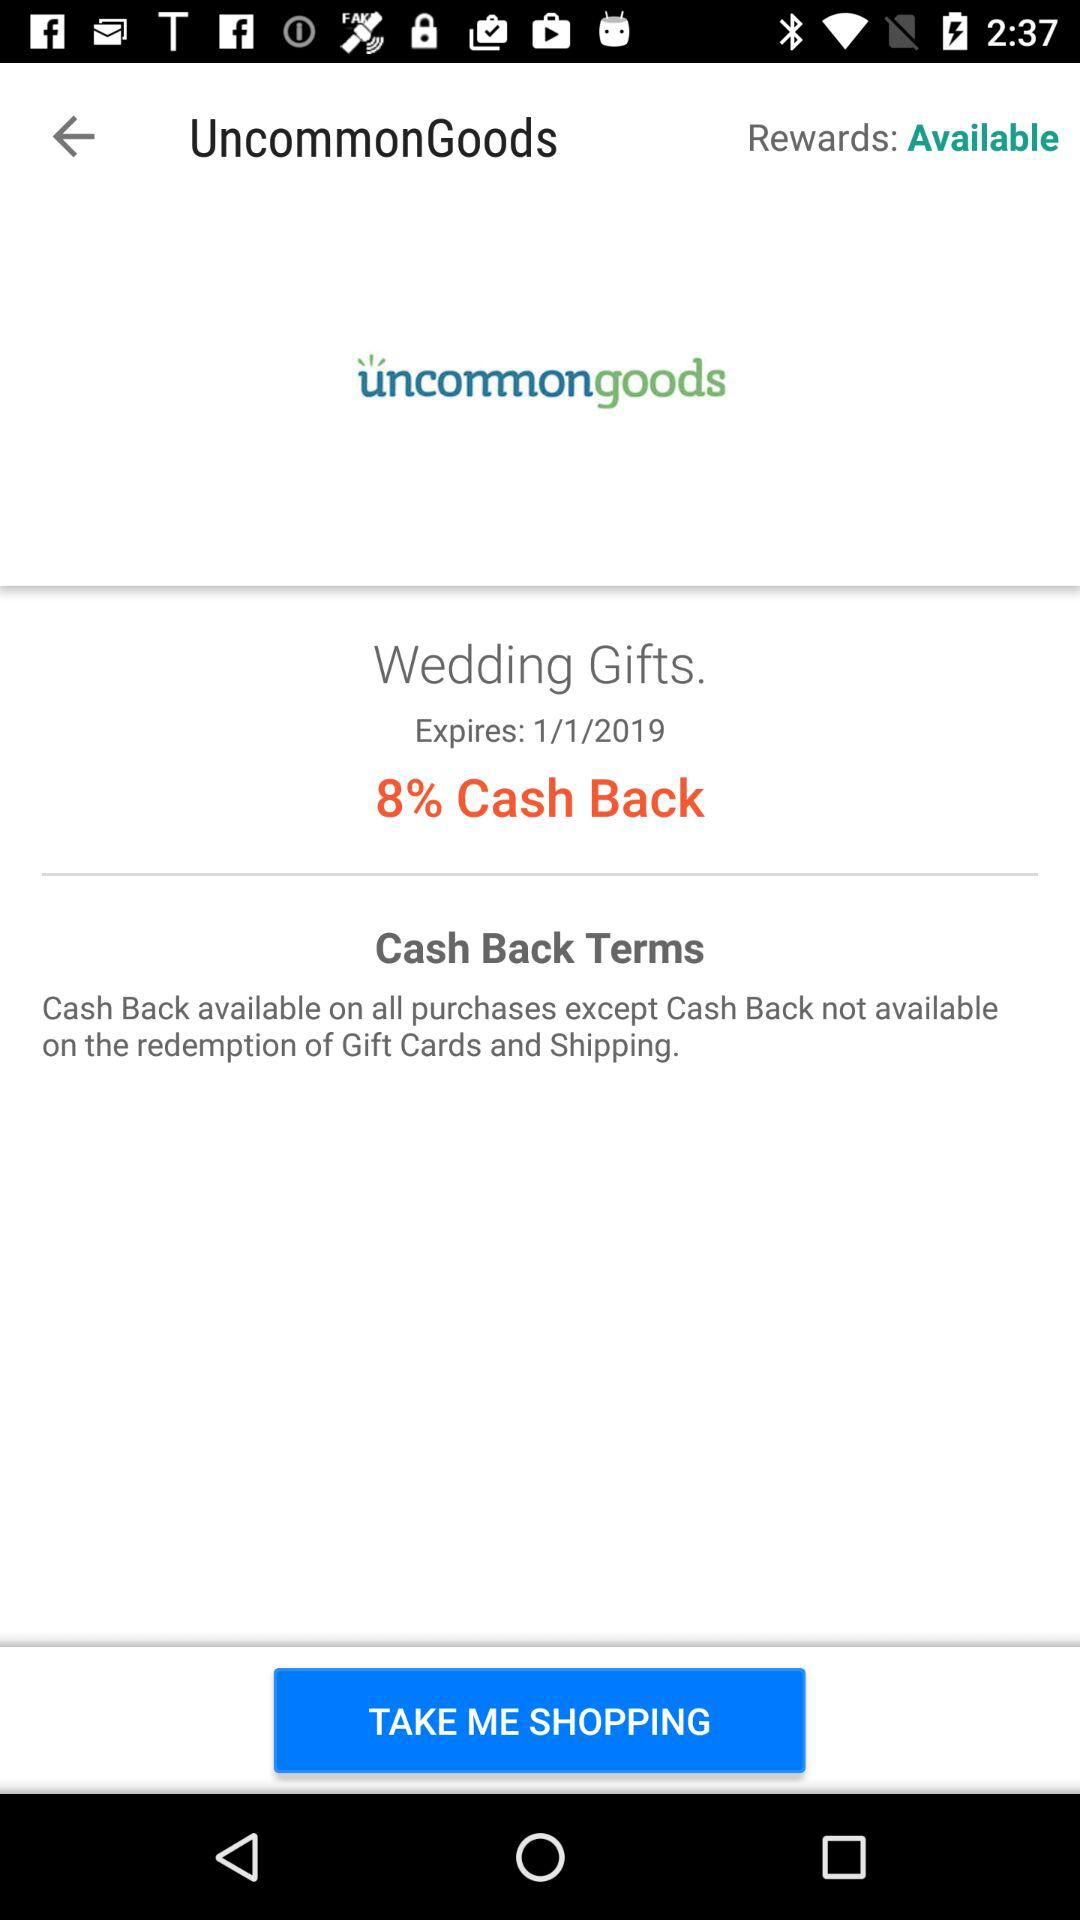What is the percentage of the cash back offer?
Answer the question using a single word or phrase. 8% 